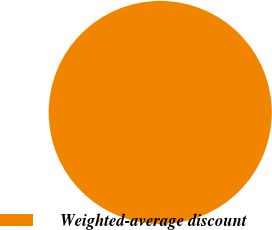Convert chart. <chart><loc_0><loc_0><loc_500><loc_500><pie_chart><fcel>Weighted-average discount<nl><fcel>100.0%<nl></chart> 